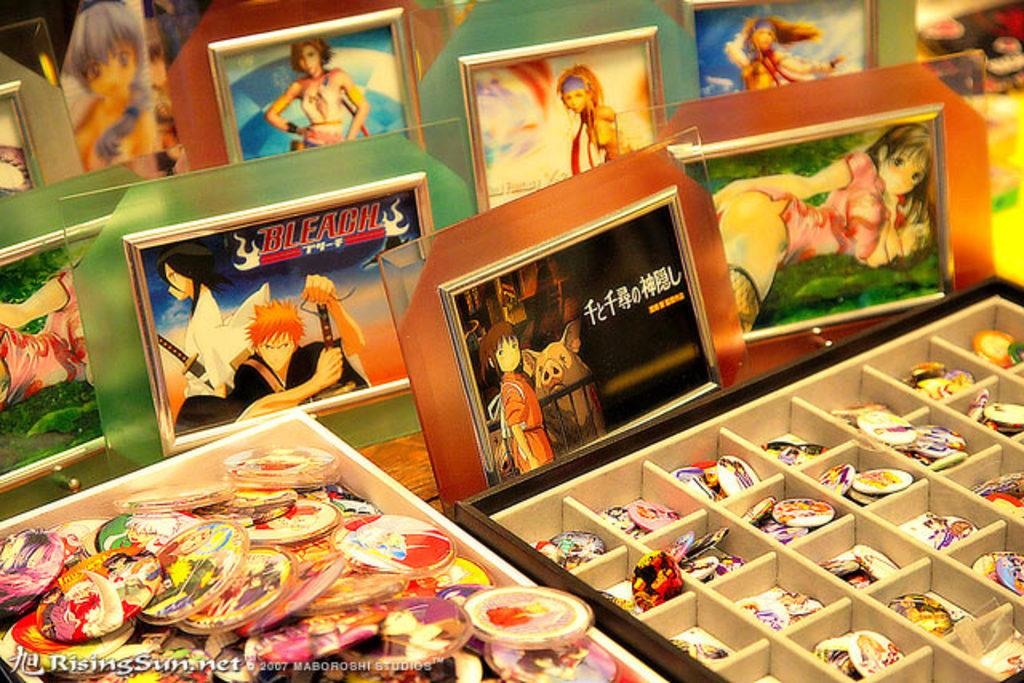What type of objects can be seen in the image? There are photo frames, a bowl of badges, and a box in the image. Where are these objects located? All of these objects are placed on a table. Can you describe the contents of the bowl in the image? The bowl contains badges. How many insects can be seen crawling on the photo frames in the image? There are no insects present in the image; it only features photo frames, a bowl of badges, and a box. 